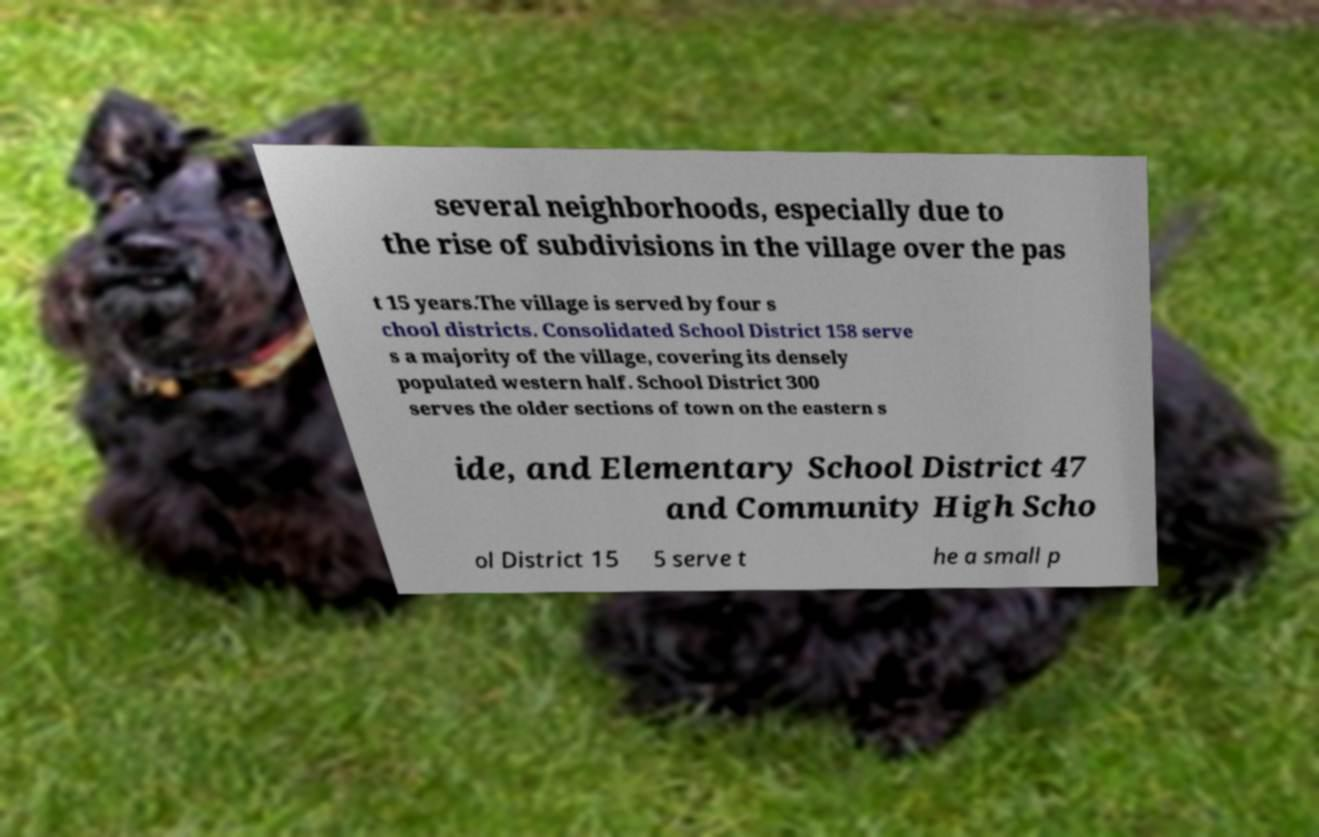For documentation purposes, I need the text within this image transcribed. Could you provide that? several neighborhoods, especially due to the rise of subdivisions in the village over the pas t 15 years.The village is served by four s chool districts. Consolidated School District 158 serve s a majority of the village, covering its densely populated western half. School District 300 serves the older sections of town on the eastern s ide, and Elementary School District 47 and Community High Scho ol District 15 5 serve t he a small p 